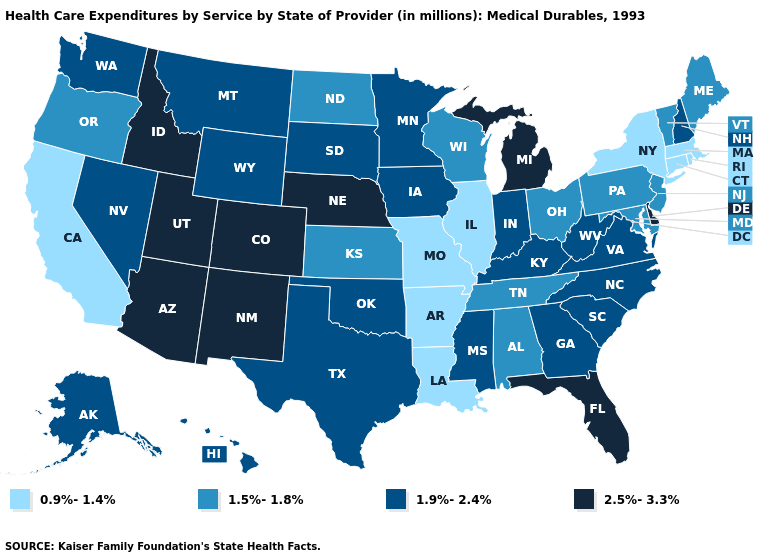Name the states that have a value in the range 2.5%-3.3%?
Short answer required. Arizona, Colorado, Delaware, Florida, Idaho, Michigan, Nebraska, New Mexico, Utah. What is the value of Idaho?
Answer briefly. 2.5%-3.3%. What is the value of Ohio?
Give a very brief answer. 1.5%-1.8%. Among the states that border New Hampshire , does Vermont have the lowest value?
Give a very brief answer. No. Does Virginia have a higher value than Massachusetts?
Quick response, please. Yes. Does Georgia have the highest value in the South?
Give a very brief answer. No. What is the highest value in states that border Washington?
Keep it brief. 2.5%-3.3%. How many symbols are there in the legend?
Quick response, please. 4. Among the states that border Utah , which have the highest value?
Concise answer only. Arizona, Colorado, Idaho, New Mexico. Name the states that have a value in the range 2.5%-3.3%?
Be succinct. Arizona, Colorado, Delaware, Florida, Idaho, Michigan, Nebraska, New Mexico, Utah. What is the highest value in states that border Arkansas?
Short answer required. 1.9%-2.4%. Does Michigan have the highest value in the USA?
Concise answer only. Yes. Which states have the lowest value in the USA?
Short answer required. Arkansas, California, Connecticut, Illinois, Louisiana, Massachusetts, Missouri, New York, Rhode Island. Which states have the highest value in the USA?
Write a very short answer. Arizona, Colorado, Delaware, Florida, Idaho, Michigan, Nebraska, New Mexico, Utah. 